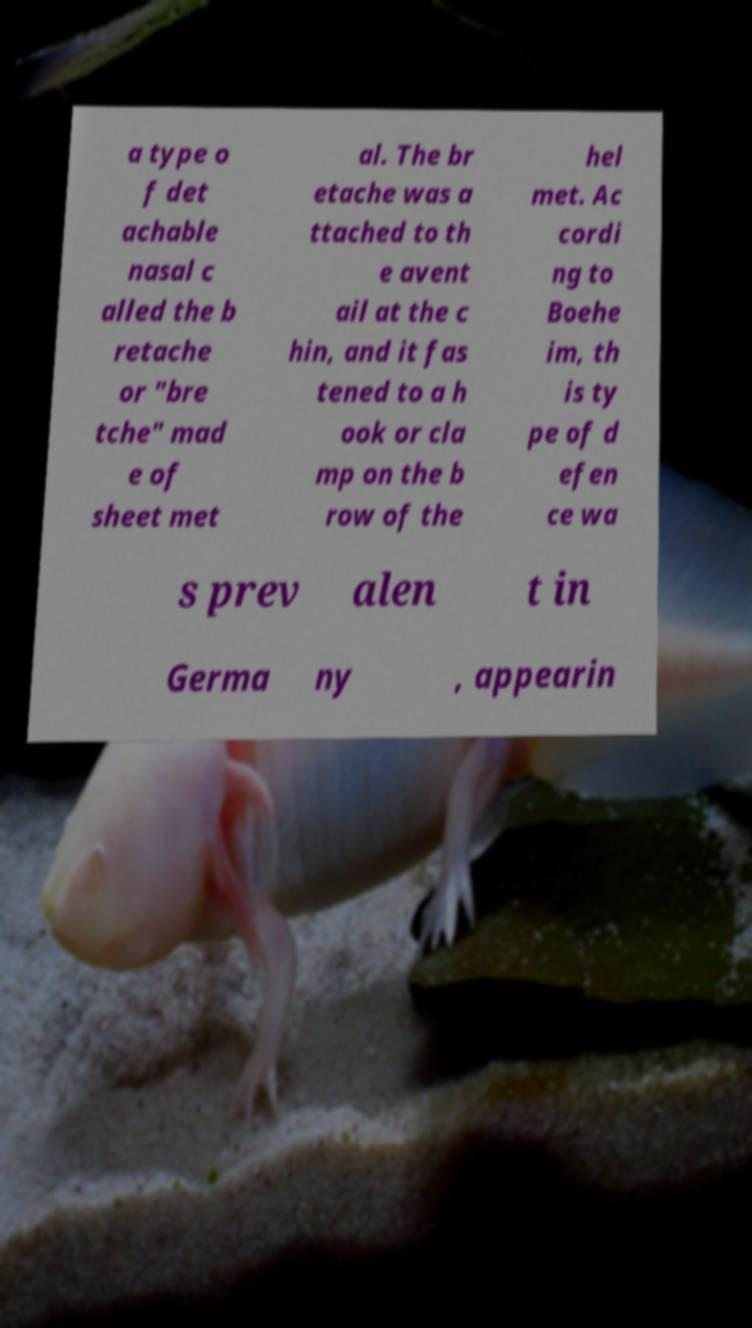I need the written content from this picture converted into text. Can you do that? a type o f det achable nasal c alled the b retache or "bre tche" mad e of sheet met al. The br etache was a ttached to th e avent ail at the c hin, and it fas tened to a h ook or cla mp on the b row of the hel met. Ac cordi ng to Boehe im, th is ty pe of d efen ce wa s prev alen t in Germa ny , appearin 